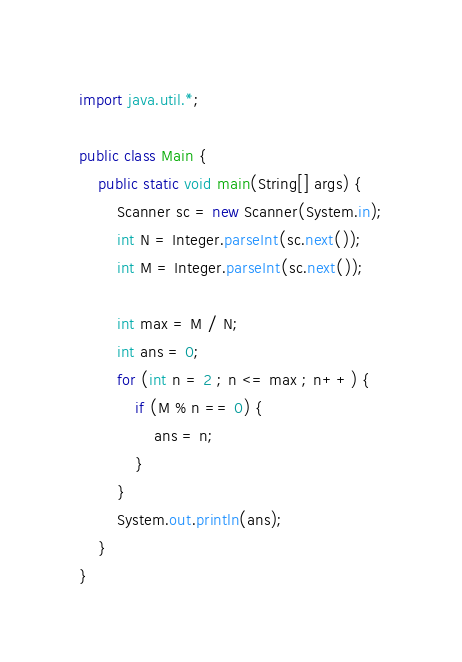Convert code to text. <code><loc_0><loc_0><loc_500><loc_500><_Java_>import java.util.*;

public class Main {
    public static void main(String[] args) {
        Scanner sc = new Scanner(System.in);
        int N = Integer.parseInt(sc.next());
        int M = Integer.parseInt(sc.next());

        int max = M / N;
        int ans = 0;
        for (int n = 2 ; n <= max ; n++) {
            if (M % n == 0) {
                ans = n;
            }
        }
        System.out.println(ans);
    }
}
</code> 